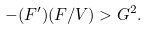Convert formula to latex. <formula><loc_0><loc_0><loc_500><loc_500>- ( { F } ^ { \prime } ) ( F / V ) > G ^ { 2 } .</formula> 